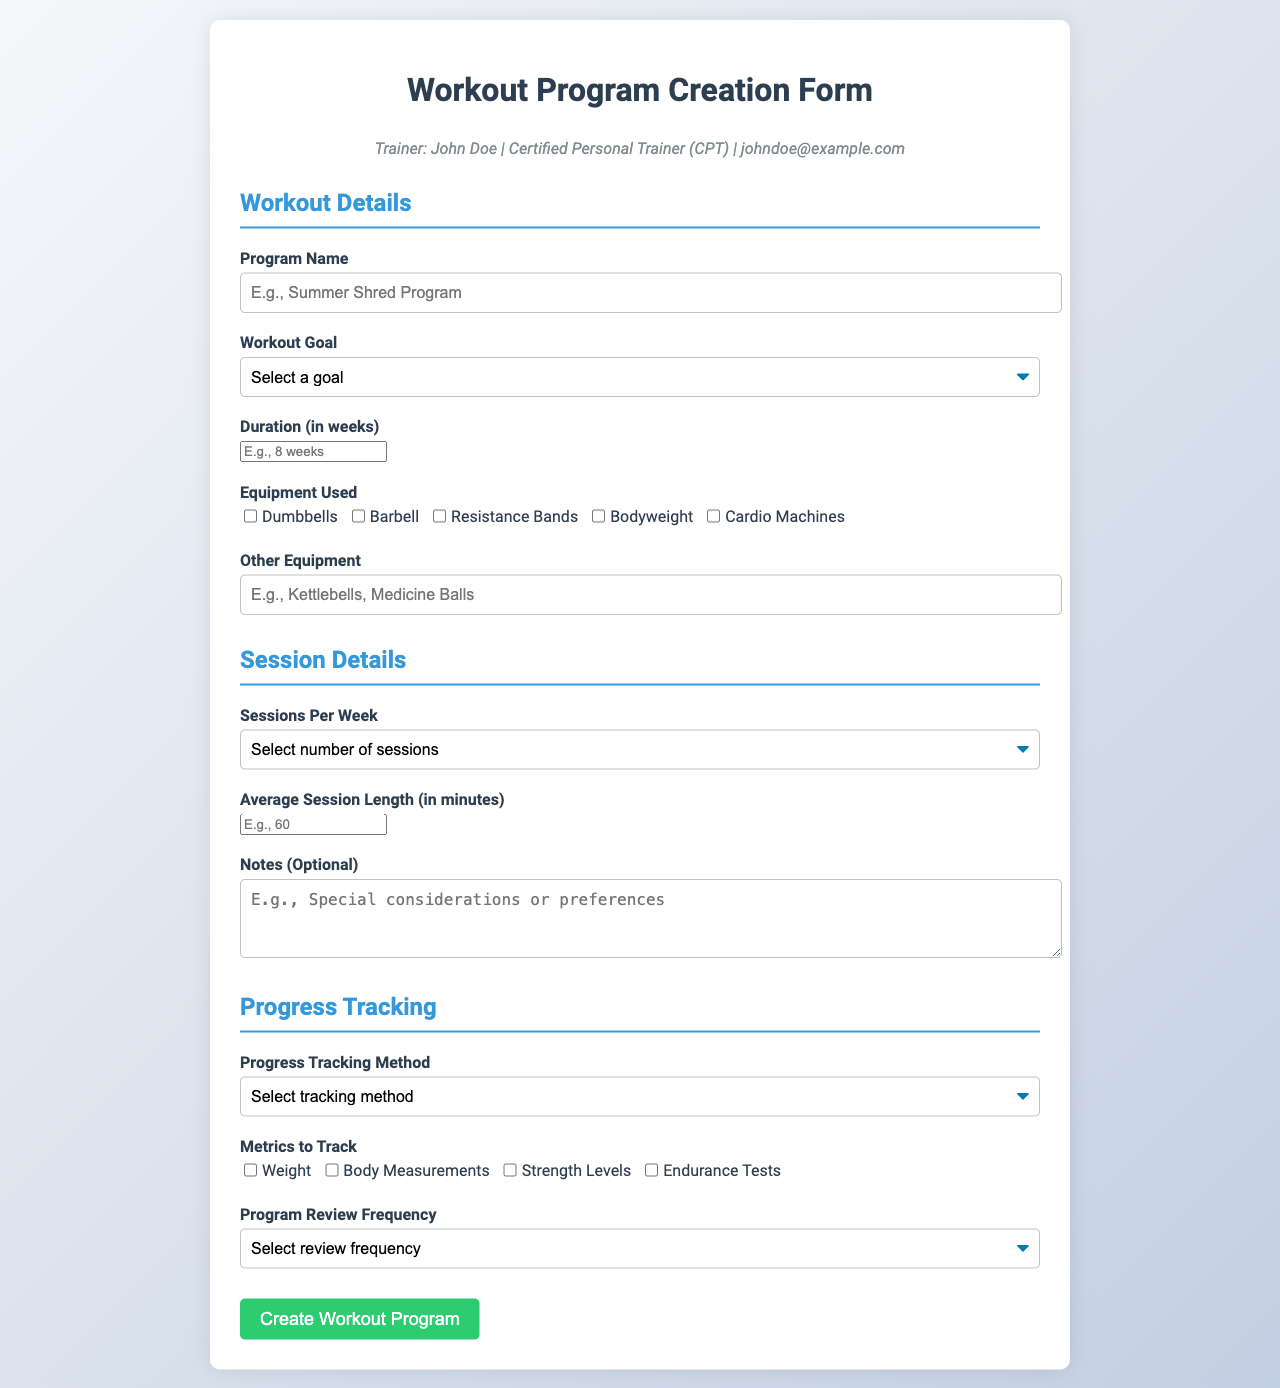What is the trainer's name? The trainer's name is shown in the trainer info section of the document.
Answer: John Doe What is the required duration for the workout program? The form specifies the required duration in the Workout Details section.
Answer: weeks How many workout goals are listed in the form? The number of workout goals is counted in the Workout Details dropdown options.
Answer: five What type of equipment can be selected? The document lists various equipment options under the Equipment Used section.
Answer: Dumbbells, Barbell, Resistance Bands, Bodyweight, Cardio Machines What is the maximum number of sessions per week that can be selected? This information is found in the Sessions Details section and represents the available options.
Answer: five What tracking method options are provided in the form? The form outlines different tracking methods in the Progress Tracking section.
Answer: Online Journal, Mobile App, Spreadsheet, Regular Check-ins What is the color theme of the form? The color theme can be inferred from the background gradient and text colors used throughout the document.
Answer: Blue and green hues What is the label for the notes field? This label can be found in the Session Details section of the form.
Answer: Notes (Optional) What is the title of the form? The title is displayed prominently at the top of the document.
Answer: Workout Program Creation Form 